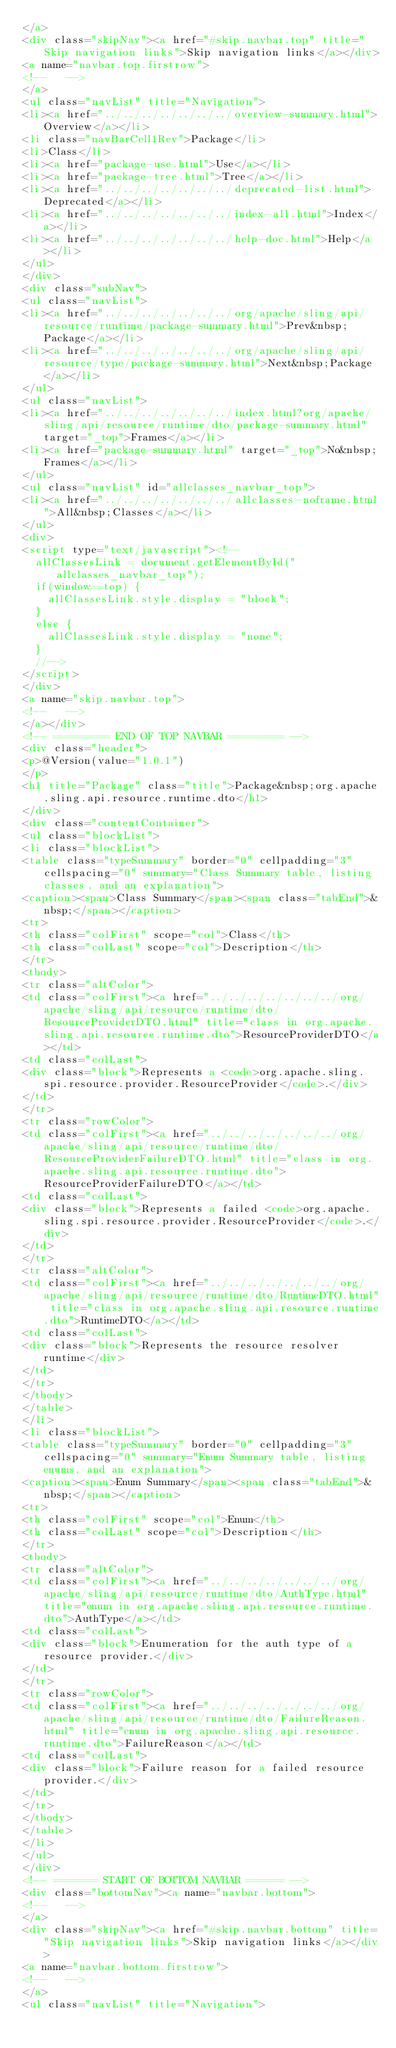Convert code to text. <code><loc_0><loc_0><loc_500><loc_500><_HTML_></a>
<div class="skipNav"><a href="#skip.navbar.top" title="Skip navigation links">Skip navigation links</a></div>
<a name="navbar.top.firstrow">
<!--   -->
</a>
<ul class="navList" title="Navigation">
<li><a href="../../../../../../../overview-summary.html">Overview</a></li>
<li class="navBarCell1Rev">Package</li>
<li>Class</li>
<li><a href="package-use.html">Use</a></li>
<li><a href="package-tree.html">Tree</a></li>
<li><a href="../../../../../../../deprecated-list.html">Deprecated</a></li>
<li><a href="../../../../../../../index-all.html">Index</a></li>
<li><a href="../../../../../../../help-doc.html">Help</a></li>
</ul>
</div>
<div class="subNav">
<ul class="navList">
<li><a href="../../../../../../../org/apache/sling/api/resource/runtime/package-summary.html">Prev&nbsp;Package</a></li>
<li><a href="../../../../../../../org/apache/sling/api/resource/type/package-summary.html">Next&nbsp;Package</a></li>
</ul>
<ul class="navList">
<li><a href="../../../../../../../index.html?org/apache/sling/api/resource/runtime/dto/package-summary.html" target="_top">Frames</a></li>
<li><a href="package-summary.html" target="_top">No&nbsp;Frames</a></li>
</ul>
<ul class="navList" id="allclasses_navbar_top">
<li><a href="../../../../../../../allclasses-noframe.html">All&nbsp;Classes</a></li>
</ul>
<div>
<script type="text/javascript"><!--
  allClassesLink = document.getElementById("allclasses_navbar_top");
  if(window==top) {
    allClassesLink.style.display = "block";
  }
  else {
    allClassesLink.style.display = "none";
  }
  //-->
</script>
</div>
<a name="skip.navbar.top">
<!--   -->
</a></div>
<!-- ========= END OF TOP NAVBAR ========= -->
<div class="header">
<p>@Version(value="1.0.1")
</p>
<h1 title="Package" class="title">Package&nbsp;org.apache.sling.api.resource.runtime.dto</h1>
</div>
<div class="contentContainer">
<ul class="blockList">
<li class="blockList">
<table class="typeSummary" border="0" cellpadding="3" cellspacing="0" summary="Class Summary table, listing classes, and an explanation">
<caption><span>Class Summary</span><span class="tabEnd">&nbsp;</span></caption>
<tr>
<th class="colFirst" scope="col">Class</th>
<th class="colLast" scope="col">Description</th>
</tr>
<tbody>
<tr class="altColor">
<td class="colFirst"><a href="../../../../../../../org/apache/sling/api/resource/runtime/dto/ResourceProviderDTO.html" title="class in org.apache.sling.api.resource.runtime.dto">ResourceProviderDTO</a></td>
<td class="colLast">
<div class="block">Represents a <code>org.apache.sling.spi.resource.provider.ResourceProvider</code>.</div>
</td>
</tr>
<tr class="rowColor">
<td class="colFirst"><a href="../../../../../../../org/apache/sling/api/resource/runtime/dto/ResourceProviderFailureDTO.html" title="class in org.apache.sling.api.resource.runtime.dto">ResourceProviderFailureDTO</a></td>
<td class="colLast">
<div class="block">Represents a failed <code>org.apache.sling.spi.resource.provider.ResourceProvider</code>.</div>
</td>
</tr>
<tr class="altColor">
<td class="colFirst"><a href="../../../../../../../org/apache/sling/api/resource/runtime/dto/RuntimeDTO.html" title="class in org.apache.sling.api.resource.runtime.dto">RuntimeDTO</a></td>
<td class="colLast">
<div class="block">Represents the resource resolver runtime</div>
</td>
</tr>
</tbody>
</table>
</li>
<li class="blockList">
<table class="typeSummary" border="0" cellpadding="3" cellspacing="0" summary="Enum Summary table, listing enums, and an explanation">
<caption><span>Enum Summary</span><span class="tabEnd">&nbsp;</span></caption>
<tr>
<th class="colFirst" scope="col">Enum</th>
<th class="colLast" scope="col">Description</th>
</tr>
<tbody>
<tr class="altColor">
<td class="colFirst"><a href="../../../../../../../org/apache/sling/api/resource/runtime/dto/AuthType.html" title="enum in org.apache.sling.api.resource.runtime.dto">AuthType</a></td>
<td class="colLast">
<div class="block">Enumeration for the auth type of a resource provider.</div>
</td>
</tr>
<tr class="rowColor">
<td class="colFirst"><a href="../../../../../../../org/apache/sling/api/resource/runtime/dto/FailureReason.html" title="enum in org.apache.sling.api.resource.runtime.dto">FailureReason</a></td>
<td class="colLast">
<div class="block">Failure reason for a failed resource provider.</div>
</td>
</tr>
</tbody>
</table>
</li>
</ul>
</div>
<!-- ======= START OF BOTTOM NAVBAR ====== -->
<div class="bottomNav"><a name="navbar.bottom">
<!--   -->
</a>
<div class="skipNav"><a href="#skip.navbar.bottom" title="Skip navigation links">Skip navigation links</a></div>
<a name="navbar.bottom.firstrow">
<!--   -->
</a>
<ul class="navList" title="Navigation"></code> 